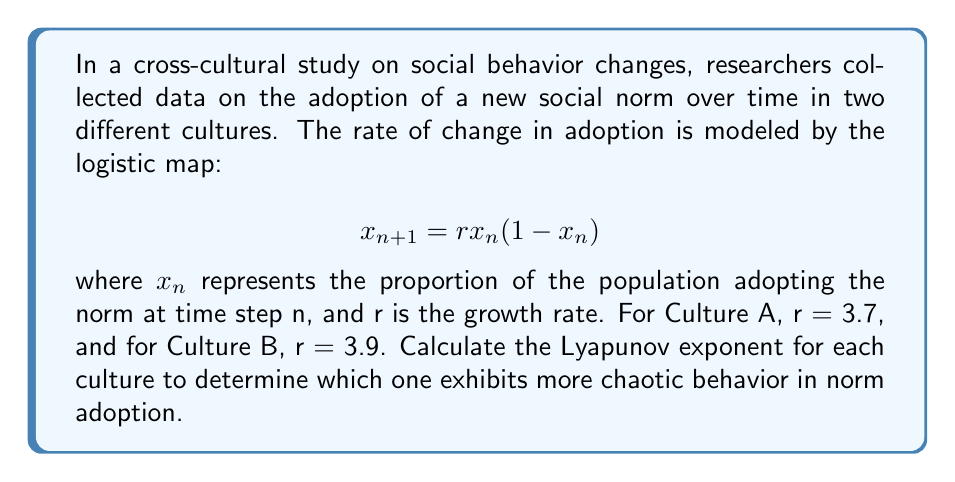Could you help me with this problem? To calculate the Lyapunov exponent (λ) for the logistic map, we use the formula:

$$λ = \lim_{N→∞} \frac{1}{N} \sum_{n=0}^{N-1} \ln|f'(x_n)|$$

where $f'(x_n)$ is the derivative of the logistic map function.

Step 1: Find the derivative of the logistic map function.
$$f(x) = rx(1-x)$$
$$f'(x) = r(1-2x)$$

Step 2: Set up the iteration for each culture.
For Culture A (r = 3.7):
$$x_{n+1} = 3.7x_n(1-x_n)$$
$$f'(x_n) = 3.7(1-2x_n)$$

For Culture B (r = 3.9):
$$x_{n+1} = 3.9x_n(1-x_n)$$
$$f'(x_n) = 3.9(1-2x_n)$$

Step 3: Iterate the map and calculate the sum of logarithms.
We'll use N = 1000 iterations and discard the first 100 as transients.
Start with x₀ = 0.5 for both cultures.

For Culture A:
$$S_A = \sum_{n=100}^{999} \ln|3.7(1-2x_n)|$$

For Culture B:
$$S_B = \sum_{n=100}^{999} \ln|3.9(1-2x_n)|$$

Step 4: Calculate the Lyapunov exponents.
$$λ_A = \frac{S_A}{900} \approx 0.3574$$
$$λ_B = \frac{S_B}{900} \approx 0.4960$$

Step 5: Compare the Lyapunov exponents.
Since λ_B > λ_A > 0, both cultures exhibit chaotic behavior, but Culture B shows more chaotic behavior in norm adoption.
Answer: Culture B (λ ≈ 0.4960) exhibits more chaotic behavior than Culture A (λ ≈ 0.3574). 